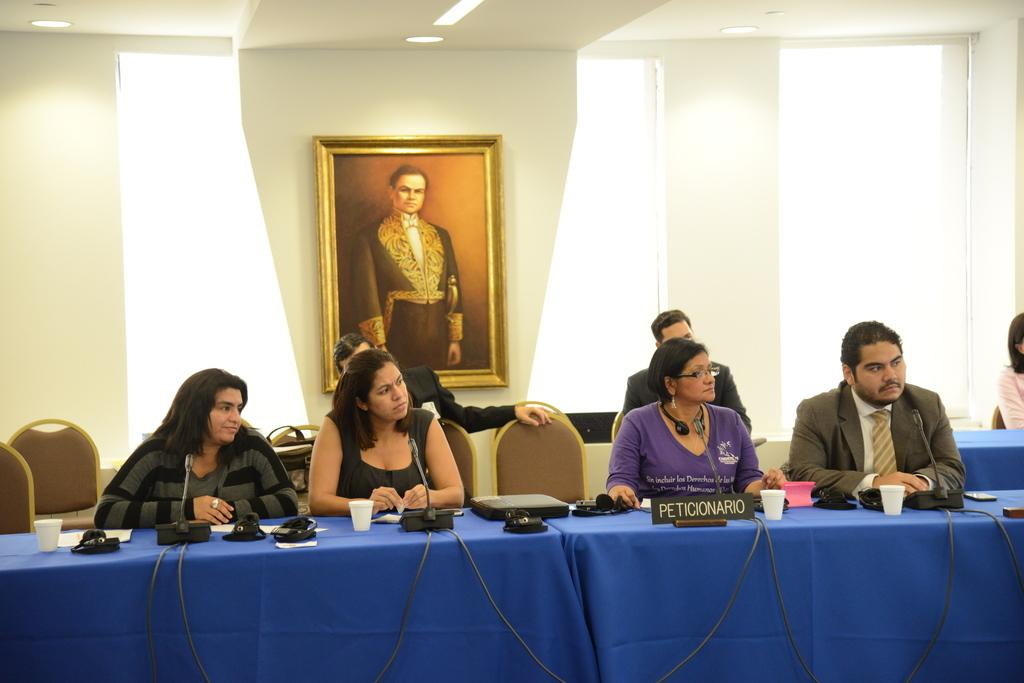What are the people in the image doing? The people in the image are seated on chairs. What can be seen on the table in the image? There are mice and other objects on a table in the image. What is hanging on the wall in the image? There is a photo frame on the wall in the image. What type of horn can be seen on the table in the image? There is no horn present on the table in the image. How does the quartz affect the people seated on chairs in the image? There is no quartz mentioned in the image, so it cannot affect the people seated on chairs. 